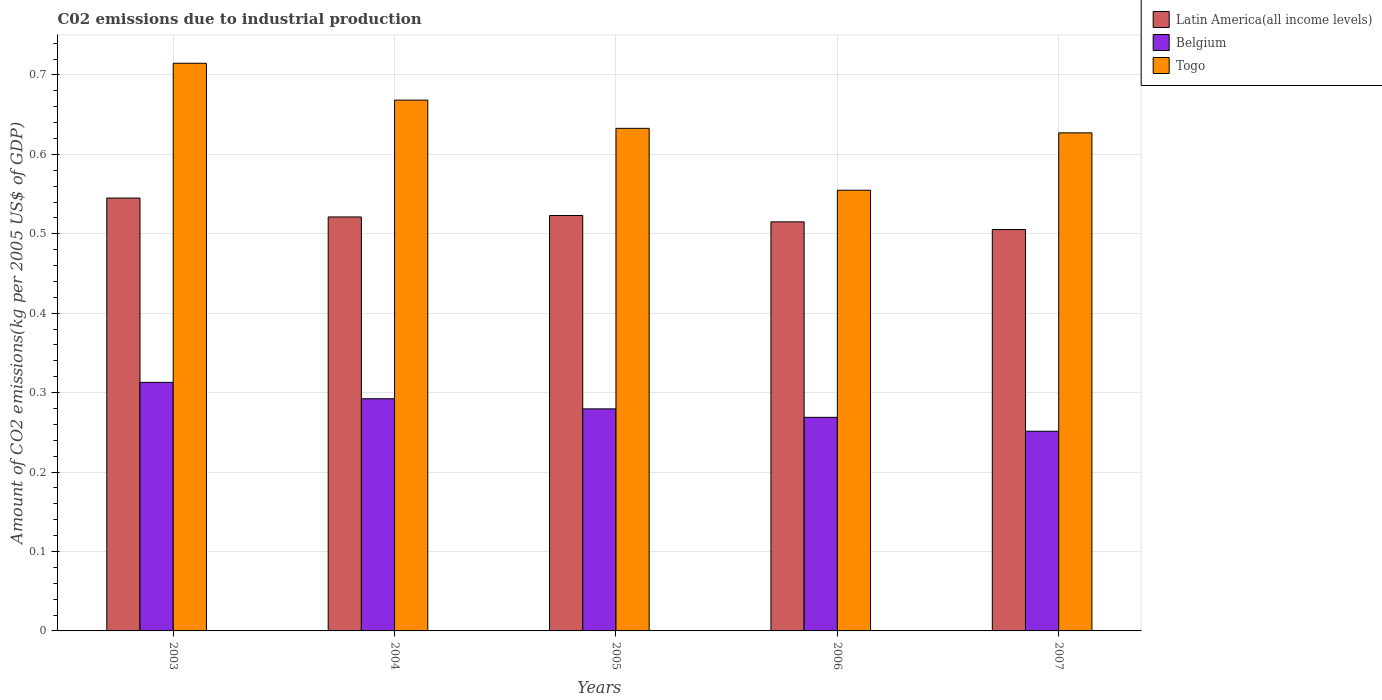How many different coloured bars are there?
Provide a succinct answer. 3. Are the number of bars per tick equal to the number of legend labels?
Ensure brevity in your answer.  Yes. How many bars are there on the 5th tick from the left?
Offer a terse response. 3. What is the label of the 1st group of bars from the left?
Ensure brevity in your answer.  2003. In how many cases, is the number of bars for a given year not equal to the number of legend labels?
Your answer should be compact. 0. What is the amount of CO2 emitted due to industrial production in Togo in 2006?
Offer a terse response. 0.55. Across all years, what is the maximum amount of CO2 emitted due to industrial production in Belgium?
Provide a short and direct response. 0.31. Across all years, what is the minimum amount of CO2 emitted due to industrial production in Togo?
Ensure brevity in your answer.  0.55. What is the total amount of CO2 emitted due to industrial production in Latin America(all income levels) in the graph?
Provide a short and direct response. 2.61. What is the difference between the amount of CO2 emitted due to industrial production in Togo in 2003 and that in 2007?
Your answer should be compact. 0.09. What is the difference between the amount of CO2 emitted due to industrial production in Belgium in 2007 and the amount of CO2 emitted due to industrial production in Togo in 2005?
Offer a terse response. -0.38. What is the average amount of CO2 emitted due to industrial production in Latin America(all income levels) per year?
Make the answer very short. 0.52. In the year 2003, what is the difference between the amount of CO2 emitted due to industrial production in Belgium and amount of CO2 emitted due to industrial production in Latin America(all income levels)?
Provide a succinct answer. -0.23. In how many years, is the amount of CO2 emitted due to industrial production in Belgium greater than 0.58 kg?
Give a very brief answer. 0. What is the ratio of the amount of CO2 emitted due to industrial production in Togo in 2003 to that in 2007?
Provide a succinct answer. 1.14. Is the amount of CO2 emitted due to industrial production in Latin America(all income levels) in 2003 less than that in 2006?
Your answer should be compact. No. Is the difference between the amount of CO2 emitted due to industrial production in Belgium in 2003 and 2006 greater than the difference between the amount of CO2 emitted due to industrial production in Latin America(all income levels) in 2003 and 2006?
Keep it short and to the point. Yes. What is the difference between the highest and the second highest amount of CO2 emitted due to industrial production in Togo?
Give a very brief answer. 0.05. What is the difference between the highest and the lowest amount of CO2 emitted due to industrial production in Togo?
Ensure brevity in your answer.  0.16. In how many years, is the amount of CO2 emitted due to industrial production in Togo greater than the average amount of CO2 emitted due to industrial production in Togo taken over all years?
Provide a succinct answer. 2. What does the 2nd bar from the left in 2004 represents?
Provide a short and direct response. Belgium. Is it the case that in every year, the sum of the amount of CO2 emitted due to industrial production in Latin America(all income levels) and amount of CO2 emitted due to industrial production in Togo is greater than the amount of CO2 emitted due to industrial production in Belgium?
Give a very brief answer. Yes. Are all the bars in the graph horizontal?
Offer a terse response. No. How many years are there in the graph?
Your answer should be compact. 5. Does the graph contain grids?
Provide a succinct answer. Yes. Where does the legend appear in the graph?
Keep it short and to the point. Top right. How are the legend labels stacked?
Offer a terse response. Vertical. What is the title of the graph?
Your answer should be very brief. C02 emissions due to industrial production. Does "Belize" appear as one of the legend labels in the graph?
Your response must be concise. No. What is the label or title of the X-axis?
Offer a terse response. Years. What is the label or title of the Y-axis?
Provide a succinct answer. Amount of CO2 emissions(kg per 2005 US$ of GDP). What is the Amount of CO2 emissions(kg per 2005 US$ of GDP) of Latin America(all income levels) in 2003?
Offer a terse response. 0.55. What is the Amount of CO2 emissions(kg per 2005 US$ of GDP) in Belgium in 2003?
Your answer should be very brief. 0.31. What is the Amount of CO2 emissions(kg per 2005 US$ of GDP) of Togo in 2003?
Your answer should be very brief. 0.71. What is the Amount of CO2 emissions(kg per 2005 US$ of GDP) in Latin America(all income levels) in 2004?
Offer a very short reply. 0.52. What is the Amount of CO2 emissions(kg per 2005 US$ of GDP) in Belgium in 2004?
Your response must be concise. 0.29. What is the Amount of CO2 emissions(kg per 2005 US$ of GDP) of Togo in 2004?
Provide a short and direct response. 0.67. What is the Amount of CO2 emissions(kg per 2005 US$ of GDP) in Latin America(all income levels) in 2005?
Your answer should be very brief. 0.52. What is the Amount of CO2 emissions(kg per 2005 US$ of GDP) in Belgium in 2005?
Make the answer very short. 0.28. What is the Amount of CO2 emissions(kg per 2005 US$ of GDP) of Togo in 2005?
Give a very brief answer. 0.63. What is the Amount of CO2 emissions(kg per 2005 US$ of GDP) of Latin America(all income levels) in 2006?
Keep it short and to the point. 0.52. What is the Amount of CO2 emissions(kg per 2005 US$ of GDP) of Belgium in 2006?
Offer a very short reply. 0.27. What is the Amount of CO2 emissions(kg per 2005 US$ of GDP) in Togo in 2006?
Give a very brief answer. 0.55. What is the Amount of CO2 emissions(kg per 2005 US$ of GDP) in Latin America(all income levels) in 2007?
Give a very brief answer. 0.51. What is the Amount of CO2 emissions(kg per 2005 US$ of GDP) in Belgium in 2007?
Your answer should be compact. 0.25. What is the Amount of CO2 emissions(kg per 2005 US$ of GDP) in Togo in 2007?
Offer a very short reply. 0.63. Across all years, what is the maximum Amount of CO2 emissions(kg per 2005 US$ of GDP) of Latin America(all income levels)?
Your answer should be very brief. 0.55. Across all years, what is the maximum Amount of CO2 emissions(kg per 2005 US$ of GDP) in Belgium?
Provide a short and direct response. 0.31. Across all years, what is the maximum Amount of CO2 emissions(kg per 2005 US$ of GDP) in Togo?
Provide a short and direct response. 0.71. Across all years, what is the minimum Amount of CO2 emissions(kg per 2005 US$ of GDP) in Latin America(all income levels)?
Give a very brief answer. 0.51. Across all years, what is the minimum Amount of CO2 emissions(kg per 2005 US$ of GDP) in Belgium?
Make the answer very short. 0.25. Across all years, what is the minimum Amount of CO2 emissions(kg per 2005 US$ of GDP) of Togo?
Give a very brief answer. 0.55. What is the total Amount of CO2 emissions(kg per 2005 US$ of GDP) in Latin America(all income levels) in the graph?
Provide a short and direct response. 2.61. What is the total Amount of CO2 emissions(kg per 2005 US$ of GDP) of Belgium in the graph?
Give a very brief answer. 1.41. What is the total Amount of CO2 emissions(kg per 2005 US$ of GDP) of Togo in the graph?
Your answer should be compact. 3.2. What is the difference between the Amount of CO2 emissions(kg per 2005 US$ of GDP) of Latin America(all income levels) in 2003 and that in 2004?
Your answer should be compact. 0.02. What is the difference between the Amount of CO2 emissions(kg per 2005 US$ of GDP) in Belgium in 2003 and that in 2004?
Your response must be concise. 0.02. What is the difference between the Amount of CO2 emissions(kg per 2005 US$ of GDP) of Togo in 2003 and that in 2004?
Provide a succinct answer. 0.05. What is the difference between the Amount of CO2 emissions(kg per 2005 US$ of GDP) of Latin America(all income levels) in 2003 and that in 2005?
Ensure brevity in your answer.  0.02. What is the difference between the Amount of CO2 emissions(kg per 2005 US$ of GDP) in Belgium in 2003 and that in 2005?
Your answer should be compact. 0.03. What is the difference between the Amount of CO2 emissions(kg per 2005 US$ of GDP) of Togo in 2003 and that in 2005?
Offer a terse response. 0.08. What is the difference between the Amount of CO2 emissions(kg per 2005 US$ of GDP) of Latin America(all income levels) in 2003 and that in 2006?
Your answer should be very brief. 0.03. What is the difference between the Amount of CO2 emissions(kg per 2005 US$ of GDP) in Belgium in 2003 and that in 2006?
Provide a succinct answer. 0.04. What is the difference between the Amount of CO2 emissions(kg per 2005 US$ of GDP) of Togo in 2003 and that in 2006?
Offer a terse response. 0.16. What is the difference between the Amount of CO2 emissions(kg per 2005 US$ of GDP) of Latin America(all income levels) in 2003 and that in 2007?
Ensure brevity in your answer.  0.04. What is the difference between the Amount of CO2 emissions(kg per 2005 US$ of GDP) in Belgium in 2003 and that in 2007?
Give a very brief answer. 0.06. What is the difference between the Amount of CO2 emissions(kg per 2005 US$ of GDP) in Togo in 2003 and that in 2007?
Provide a short and direct response. 0.09. What is the difference between the Amount of CO2 emissions(kg per 2005 US$ of GDP) in Latin America(all income levels) in 2004 and that in 2005?
Offer a terse response. -0. What is the difference between the Amount of CO2 emissions(kg per 2005 US$ of GDP) in Belgium in 2004 and that in 2005?
Make the answer very short. 0.01. What is the difference between the Amount of CO2 emissions(kg per 2005 US$ of GDP) in Togo in 2004 and that in 2005?
Offer a terse response. 0.04. What is the difference between the Amount of CO2 emissions(kg per 2005 US$ of GDP) in Latin America(all income levels) in 2004 and that in 2006?
Your response must be concise. 0.01. What is the difference between the Amount of CO2 emissions(kg per 2005 US$ of GDP) of Belgium in 2004 and that in 2006?
Give a very brief answer. 0.02. What is the difference between the Amount of CO2 emissions(kg per 2005 US$ of GDP) of Togo in 2004 and that in 2006?
Provide a succinct answer. 0.11. What is the difference between the Amount of CO2 emissions(kg per 2005 US$ of GDP) in Latin America(all income levels) in 2004 and that in 2007?
Your response must be concise. 0.02. What is the difference between the Amount of CO2 emissions(kg per 2005 US$ of GDP) in Belgium in 2004 and that in 2007?
Provide a short and direct response. 0.04. What is the difference between the Amount of CO2 emissions(kg per 2005 US$ of GDP) of Togo in 2004 and that in 2007?
Offer a terse response. 0.04. What is the difference between the Amount of CO2 emissions(kg per 2005 US$ of GDP) of Latin America(all income levels) in 2005 and that in 2006?
Give a very brief answer. 0.01. What is the difference between the Amount of CO2 emissions(kg per 2005 US$ of GDP) in Belgium in 2005 and that in 2006?
Your answer should be very brief. 0.01. What is the difference between the Amount of CO2 emissions(kg per 2005 US$ of GDP) of Togo in 2005 and that in 2006?
Keep it short and to the point. 0.08. What is the difference between the Amount of CO2 emissions(kg per 2005 US$ of GDP) in Latin America(all income levels) in 2005 and that in 2007?
Ensure brevity in your answer.  0.02. What is the difference between the Amount of CO2 emissions(kg per 2005 US$ of GDP) of Belgium in 2005 and that in 2007?
Your answer should be very brief. 0.03. What is the difference between the Amount of CO2 emissions(kg per 2005 US$ of GDP) of Togo in 2005 and that in 2007?
Offer a terse response. 0.01. What is the difference between the Amount of CO2 emissions(kg per 2005 US$ of GDP) of Latin America(all income levels) in 2006 and that in 2007?
Your response must be concise. 0.01. What is the difference between the Amount of CO2 emissions(kg per 2005 US$ of GDP) in Belgium in 2006 and that in 2007?
Offer a very short reply. 0.02. What is the difference between the Amount of CO2 emissions(kg per 2005 US$ of GDP) in Togo in 2006 and that in 2007?
Your answer should be compact. -0.07. What is the difference between the Amount of CO2 emissions(kg per 2005 US$ of GDP) of Latin America(all income levels) in 2003 and the Amount of CO2 emissions(kg per 2005 US$ of GDP) of Belgium in 2004?
Provide a succinct answer. 0.25. What is the difference between the Amount of CO2 emissions(kg per 2005 US$ of GDP) in Latin America(all income levels) in 2003 and the Amount of CO2 emissions(kg per 2005 US$ of GDP) in Togo in 2004?
Your answer should be very brief. -0.12. What is the difference between the Amount of CO2 emissions(kg per 2005 US$ of GDP) of Belgium in 2003 and the Amount of CO2 emissions(kg per 2005 US$ of GDP) of Togo in 2004?
Offer a very short reply. -0.36. What is the difference between the Amount of CO2 emissions(kg per 2005 US$ of GDP) of Latin America(all income levels) in 2003 and the Amount of CO2 emissions(kg per 2005 US$ of GDP) of Belgium in 2005?
Give a very brief answer. 0.27. What is the difference between the Amount of CO2 emissions(kg per 2005 US$ of GDP) of Latin America(all income levels) in 2003 and the Amount of CO2 emissions(kg per 2005 US$ of GDP) of Togo in 2005?
Offer a terse response. -0.09. What is the difference between the Amount of CO2 emissions(kg per 2005 US$ of GDP) of Belgium in 2003 and the Amount of CO2 emissions(kg per 2005 US$ of GDP) of Togo in 2005?
Keep it short and to the point. -0.32. What is the difference between the Amount of CO2 emissions(kg per 2005 US$ of GDP) of Latin America(all income levels) in 2003 and the Amount of CO2 emissions(kg per 2005 US$ of GDP) of Belgium in 2006?
Offer a terse response. 0.28. What is the difference between the Amount of CO2 emissions(kg per 2005 US$ of GDP) of Latin America(all income levels) in 2003 and the Amount of CO2 emissions(kg per 2005 US$ of GDP) of Togo in 2006?
Keep it short and to the point. -0.01. What is the difference between the Amount of CO2 emissions(kg per 2005 US$ of GDP) of Belgium in 2003 and the Amount of CO2 emissions(kg per 2005 US$ of GDP) of Togo in 2006?
Your answer should be compact. -0.24. What is the difference between the Amount of CO2 emissions(kg per 2005 US$ of GDP) in Latin America(all income levels) in 2003 and the Amount of CO2 emissions(kg per 2005 US$ of GDP) in Belgium in 2007?
Offer a terse response. 0.29. What is the difference between the Amount of CO2 emissions(kg per 2005 US$ of GDP) of Latin America(all income levels) in 2003 and the Amount of CO2 emissions(kg per 2005 US$ of GDP) of Togo in 2007?
Ensure brevity in your answer.  -0.08. What is the difference between the Amount of CO2 emissions(kg per 2005 US$ of GDP) in Belgium in 2003 and the Amount of CO2 emissions(kg per 2005 US$ of GDP) in Togo in 2007?
Provide a short and direct response. -0.31. What is the difference between the Amount of CO2 emissions(kg per 2005 US$ of GDP) of Latin America(all income levels) in 2004 and the Amount of CO2 emissions(kg per 2005 US$ of GDP) of Belgium in 2005?
Make the answer very short. 0.24. What is the difference between the Amount of CO2 emissions(kg per 2005 US$ of GDP) of Latin America(all income levels) in 2004 and the Amount of CO2 emissions(kg per 2005 US$ of GDP) of Togo in 2005?
Provide a short and direct response. -0.11. What is the difference between the Amount of CO2 emissions(kg per 2005 US$ of GDP) of Belgium in 2004 and the Amount of CO2 emissions(kg per 2005 US$ of GDP) of Togo in 2005?
Your answer should be compact. -0.34. What is the difference between the Amount of CO2 emissions(kg per 2005 US$ of GDP) of Latin America(all income levels) in 2004 and the Amount of CO2 emissions(kg per 2005 US$ of GDP) of Belgium in 2006?
Make the answer very short. 0.25. What is the difference between the Amount of CO2 emissions(kg per 2005 US$ of GDP) in Latin America(all income levels) in 2004 and the Amount of CO2 emissions(kg per 2005 US$ of GDP) in Togo in 2006?
Your answer should be compact. -0.03. What is the difference between the Amount of CO2 emissions(kg per 2005 US$ of GDP) of Belgium in 2004 and the Amount of CO2 emissions(kg per 2005 US$ of GDP) of Togo in 2006?
Provide a succinct answer. -0.26. What is the difference between the Amount of CO2 emissions(kg per 2005 US$ of GDP) in Latin America(all income levels) in 2004 and the Amount of CO2 emissions(kg per 2005 US$ of GDP) in Belgium in 2007?
Your answer should be compact. 0.27. What is the difference between the Amount of CO2 emissions(kg per 2005 US$ of GDP) in Latin America(all income levels) in 2004 and the Amount of CO2 emissions(kg per 2005 US$ of GDP) in Togo in 2007?
Make the answer very short. -0.11. What is the difference between the Amount of CO2 emissions(kg per 2005 US$ of GDP) in Belgium in 2004 and the Amount of CO2 emissions(kg per 2005 US$ of GDP) in Togo in 2007?
Give a very brief answer. -0.33. What is the difference between the Amount of CO2 emissions(kg per 2005 US$ of GDP) of Latin America(all income levels) in 2005 and the Amount of CO2 emissions(kg per 2005 US$ of GDP) of Belgium in 2006?
Provide a short and direct response. 0.25. What is the difference between the Amount of CO2 emissions(kg per 2005 US$ of GDP) of Latin America(all income levels) in 2005 and the Amount of CO2 emissions(kg per 2005 US$ of GDP) of Togo in 2006?
Your answer should be very brief. -0.03. What is the difference between the Amount of CO2 emissions(kg per 2005 US$ of GDP) in Belgium in 2005 and the Amount of CO2 emissions(kg per 2005 US$ of GDP) in Togo in 2006?
Ensure brevity in your answer.  -0.28. What is the difference between the Amount of CO2 emissions(kg per 2005 US$ of GDP) in Latin America(all income levels) in 2005 and the Amount of CO2 emissions(kg per 2005 US$ of GDP) in Belgium in 2007?
Your answer should be very brief. 0.27. What is the difference between the Amount of CO2 emissions(kg per 2005 US$ of GDP) in Latin America(all income levels) in 2005 and the Amount of CO2 emissions(kg per 2005 US$ of GDP) in Togo in 2007?
Ensure brevity in your answer.  -0.1. What is the difference between the Amount of CO2 emissions(kg per 2005 US$ of GDP) of Belgium in 2005 and the Amount of CO2 emissions(kg per 2005 US$ of GDP) of Togo in 2007?
Keep it short and to the point. -0.35. What is the difference between the Amount of CO2 emissions(kg per 2005 US$ of GDP) in Latin America(all income levels) in 2006 and the Amount of CO2 emissions(kg per 2005 US$ of GDP) in Belgium in 2007?
Your response must be concise. 0.26. What is the difference between the Amount of CO2 emissions(kg per 2005 US$ of GDP) of Latin America(all income levels) in 2006 and the Amount of CO2 emissions(kg per 2005 US$ of GDP) of Togo in 2007?
Your answer should be compact. -0.11. What is the difference between the Amount of CO2 emissions(kg per 2005 US$ of GDP) of Belgium in 2006 and the Amount of CO2 emissions(kg per 2005 US$ of GDP) of Togo in 2007?
Make the answer very short. -0.36. What is the average Amount of CO2 emissions(kg per 2005 US$ of GDP) in Latin America(all income levels) per year?
Your response must be concise. 0.52. What is the average Amount of CO2 emissions(kg per 2005 US$ of GDP) of Belgium per year?
Provide a succinct answer. 0.28. What is the average Amount of CO2 emissions(kg per 2005 US$ of GDP) in Togo per year?
Make the answer very short. 0.64. In the year 2003, what is the difference between the Amount of CO2 emissions(kg per 2005 US$ of GDP) of Latin America(all income levels) and Amount of CO2 emissions(kg per 2005 US$ of GDP) of Belgium?
Your answer should be compact. 0.23. In the year 2003, what is the difference between the Amount of CO2 emissions(kg per 2005 US$ of GDP) in Latin America(all income levels) and Amount of CO2 emissions(kg per 2005 US$ of GDP) in Togo?
Make the answer very short. -0.17. In the year 2003, what is the difference between the Amount of CO2 emissions(kg per 2005 US$ of GDP) in Belgium and Amount of CO2 emissions(kg per 2005 US$ of GDP) in Togo?
Your answer should be very brief. -0.4. In the year 2004, what is the difference between the Amount of CO2 emissions(kg per 2005 US$ of GDP) of Latin America(all income levels) and Amount of CO2 emissions(kg per 2005 US$ of GDP) of Belgium?
Your answer should be compact. 0.23. In the year 2004, what is the difference between the Amount of CO2 emissions(kg per 2005 US$ of GDP) in Latin America(all income levels) and Amount of CO2 emissions(kg per 2005 US$ of GDP) in Togo?
Provide a short and direct response. -0.15. In the year 2004, what is the difference between the Amount of CO2 emissions(kg per 2005 US$ of GDP) of Belgium and Amount of CO2 emissions(kg per 2005 US$ of GDP) of Togo?
Provide a short and direct response. -0.38. In the year 2005, what is the difference between the Amount of CO2 emissions(kg per 2005 US$ of GDP) of Latin America(all income levels) and Amount of CO2 emissions(kg per 2005 US$ of GDP) of Belgium?
Your answer should be very brief. 0.24. In the year 2005, what is the difference between the Amount of CO2 emissions(kg per 2005 US$ of GDP) in Latin America(all income levels) and Amount of CO2 emissions(kg per 2005 US$ of GDP) in Togo?
Offer a terse response. -0.11. In the year 2005, what is the difference between the Amount of CO2 emissions(kg per 2005 US$ of GDP) of Belgium and Amount of CO2 emissions(kg per 2005 US$ of GDP) of Togo?
Your response must be concise. -0.35. In the year 2006, what is the difference between the Amount of CO2 emissions(kg per 2005 US$ of GDP) of Latin America(all income levels) and Amount of CO2 emissions(kg per 2005 US$ of GDP) of Belgium?
Make the answer very short. 0.25. In the year 2006, what is the difference between the Amount of CO2 emissions(kg per 2005 US$ of GDP) of Latin America(all income levels) and Amount of CO2 emissions(kg per 2005 US$ of GDP) of Togo?
Ensure brevity in your answer.  -0.04. In the year 2006, what is the difference between the Amount of CO2 emissions(kg per 2005 US$ of GDP) in Belgium and Amount of CO2 emissions(kg per 2005 US$ of GDP) in Togo?
Your answer should be compact. -0.29. In the year 2007, what is the difference between the Amount of CO2 emissions(kg per 2005 US$ of GDP) of Latin America(all income levels) and Amount of CO2 emissions(kg per 2005 US$ of GDP) of Belgium?
Ensure brevity in your answer.  0.25. In the year 2007, what is the difference between the Amount of CO2 emissions(kg per 2005 US$ of GDP) of Latin America(all income levels) and Amount of CO2 emissions(kg per 2005 US$ of GDP) of Togo?
Keep it short and to the point. -0.12. In the year 2007, what is the difference between the Amount of CO2 emissions(kg per 2005 US$ of GDP) of Belgium and Amount of CO2 emissions(kg per 2005 US$ of GDP) of Togo?
Provide a short and direct response. -0.38. What is the ratio of the Amount of CO2 emissions(kg per 2005 US$ of GDP) in Latin America(all income levels) in 2003 to that in 2004?
Provide a succinct answer. 1.05. What is the ratio of the Amount of CO2 emissions(kg per 2005 US$ of GDP) of Belgium in 2003 to that in 2004?
Keep it short and to the point. 1.07. What is the ratio of the Amount of CO2 emissions(kg per 2005 US$ of GDP) in Togo in 2003 to that in 2004?
Make the answer very short. 1.07. What is the ratio of the Amount of CO2 emissions(kg per 2005 US$ of GDP) in Latin America(all income levels) in 2003 to that in 2005?
Provide a short and direct response. 1.04. What is the ratio of the Amount of CO2 emissions(kg per 2005 US$ of GDP) of Belgium in 2003 to that in 2005?
Provide a short and direct response. 1.12. What is the ratio of the Amount of CO2 emissions(kg per 2005 US$ of GDP) in Togo in 2003 to that in 2005?
Your answer should be very brief. 1.13. What is the ratio of the Amount of CO2 emissions(kg per 2005 US$ of GDP) in Latin America(all income levels) in 2003 to that in 2006?
Your response must be concise. 1.06. What is the ratio of the Amount of CO2 emissions(kg per 2005 US$ of GDP) in Belgium in 2003 to that in 2006?
Make the answer very short. 1.16. What is the ratio of the Amount of CO2 emissions(kg per 2005 US$ of GDP) in Togo in 2003 to that in 2006?
Your response must be concise. 1.29. What is the ratio of the Amount of CO2 emissions(kg per 2005 US$ of GDP) of Latin America(all income levels) in 2003 to that in 2007?
Provide a succinct answer. 1.08. What is the ratio of the Amount of CO2 emissions(kg per 2005 US$ of GDP) of Belgium in 2003 to that in 2007?
Your answer should be very brief. 1.24. What is the ratio of the Amount of CO2 emissions(kg per 2005 US$ of GDP) of Togo in 2003 to that in 2007?
Offer a terse response. 1.14. What is the ratio of the Amount of CO2 emissions(kg per 2005 US$ of GDP) in Latin America(all income levels) in 2004 to that in 2005?
Provide a succinct answer. 1. What is the ratio of the Amount of CO2 emissions(kg per 2005 US$ of GDP) of Belgium in 2004 to that in 2005?
Your response must be concise. 1.05. What is the ratio of the Amount of CO2 emissions(kg per 2005 US$ of GDP) of Togo in 2004 to that in 2005?
Offer a very short reply. 1.06. What is the ratio of the Amount of CO2 emissions(kg per 2005 US$ of GDP) of Latin America(all income levels) in 2004 to that in 2006?
Offer a very short reply. 1.01. What is the ratio of the Amount of CO2 emissions(kg per 2005 US$ of GDP) of Belgium in 2004 to that in 2006?
Make the answer very short. 1.09. What is the ratio of the Amount of CO2 emissions(kg per 2005 US$ of GDP) of Togo in 2004 to that in 2006?
Your response must be concise. 1.2. What is the ratio of the Amount of CO2 emissions(kg per 2005 US$ of GDP) of Latin America(all income levels) in 2004 to that in 2007?
Ensure brevity in your answer.  1.03. What is the ratio of the Amount of CO2 emissions(kg per 2005 US$ of GDP) in Belgium in 2004 to that in 2007?
Provide a succinct answer. 1.16. What is the ratio of the Amount of CO2 emissions(kg per 2005 US$ of GDP) in Togo in 2004 to that in 2007?
Offer a terse response. 1.07. What is the ratio of the Amount of CO2 emissions(kg per 2005 US$ of GDP) in Latin America(all income levels) in 2005 to that in 2006?
Make the answer very short. 1.02. What is the ratio of the Amount of CO2 emissions(kg per 2005 US$ of GDP) in Belgium in 2005 to that in 2006?
Provide a short and direct response. 1.04. What is the ratio of the Amount of CO2 emissions(kg per 2005 US$ of GDP) of Togo in 2005 to that in 2006?
Provide a succinct answer. 1.14. What is the ratio of the Amount of CO2 emissions(kg per 2005 US$ of GDP) of Latin America(all income levels) in 2005 to that in 2007?
Make the answer very short. 1.03. What is the ratio of the Amount of CO2 emissions(kg per 2005 US$ of GDP) of Belgium in 2005 to that in 2007?
Offer a terse response. 1.11. What is the ratio of the Amount of CO2 emissions(kg per 2005 US$ of GDP) in Togo in 2005 to that in 2007?
Provide a short and direct response. 1.01. What is the ratio of the Amount of CO2 emissions(kg per 2005 US$ of GDP) in Latin America(all income levels) in 2006 to that in 2007?
Offer a terse response. 1.02. What is the ratio of the Amount of CO2 emissions(kg per 2005 US$ of GDP) in Belgium in 2006 to that in 2007?
Your answer should be compact. 1.07. What is the ratio of the Amount of CO2 emissions(kg per 2005 US$ of GDP) of Togo in 2006 to that in 2007?
Your response must be concise. 0.88. What is the difference between the highest and the second highest Amount of CO2 emissions(kg per 2005 US$ of GDP) in Latin America(all income levels)?
Make the answer very short. 0.02. What is the difference between the highest and the second highest Amount of CO2 emissions(kg per 2005 US$ of GDP) of Belgium?
Give a very brief answer. 0.02. What is the difference between the highest and the second highest Amount of CO2 emissions(kg per 2005 US$ of GDP) in Togo?
Make the answer very short. 0.05. What is the difference between the highest and the lowest Amount of CO2 emissions(kg per 2005 US$ of GDP) of Latin America(all income levels)?
Your answer should be very brief. 0.04. What is the difference between the highest and the lowest Amount of CO2 emissions(kg per 2005 US$ of GDP) in Belgium?
Your answer should be very brief. 0.06. What is the difference between the highest and the lowest Amount of CO2 emissions(kg per 2005 US$ of GDP) in Togo?
Offer a terse response. 0.16. 